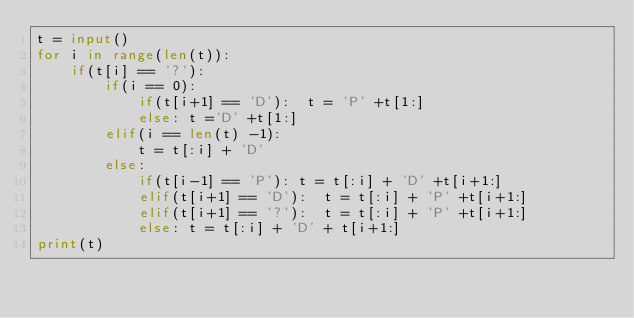<code> <loc_0><loc_0><loc_500><loc_500><_Python_>t = input()
for i in range(len(t)):
    if(t[i] == '?'):
        if(i == 0):
            if(t[i+1] == 'D'):  t = 'P' +t[1:]
            else: t ='D' +t[1:]
        elif(i == len(t) -1):
            t = t[:i] + 'D'
        else:
            if(t[i-1] == 'P'): t = t[:i] + 'D' +t[i+1:]
            elif(t[i+1] == 'D'):  t = t[:i] + 'P' +t[i+1:]
            elif(t[i+1] == '?'):  t = t[:i] + 'P' +t[i+1:]
            else: t = t[:i] + 'D' + t[i+1:]
print(t)</code> 